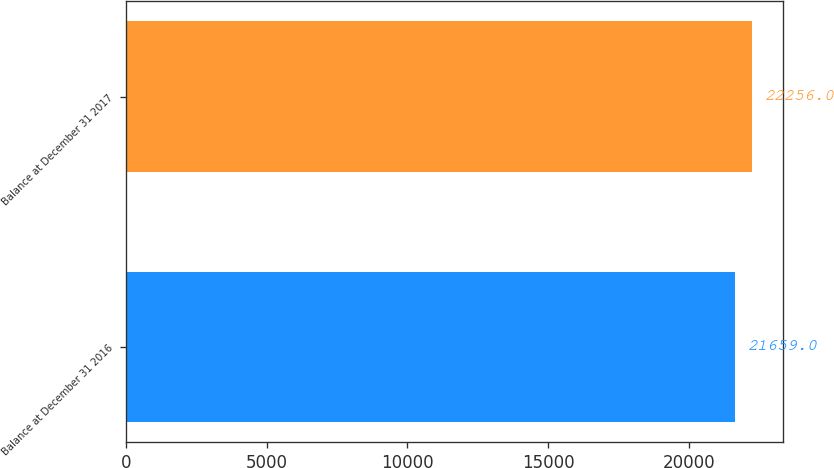Convert chart. <chart><loc_0><loc_0><loc_500><loc_500><bar_chart><fcel>Balance at December 31 2016<fcel>Balance at December 31 2017<nl><fcel>21659<fcel>22256<nl></chart> 